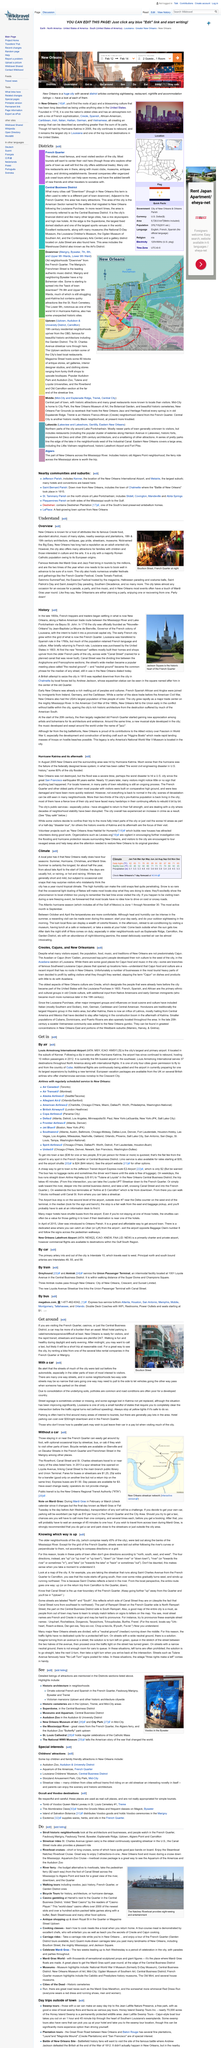Mention a couple of crucial points in this snapshot. The image in the top-right corner was taken at Bourbon Street in the French Quarter. The average temperature at daily highs in the first month of Atlantic hurricane season is 89 degrees Fahrenheit. New Orleans is commonly referred to as the "Big Easy" due to its reputation for being a laid-back and easy-going city. The New Orleans Regional Transit Authority (RTA) is the public transit option available for individuals who do not have a car and wish to travel in the city of New Orleans. You can rent a bike from either the French Quarter or the Marigny. 